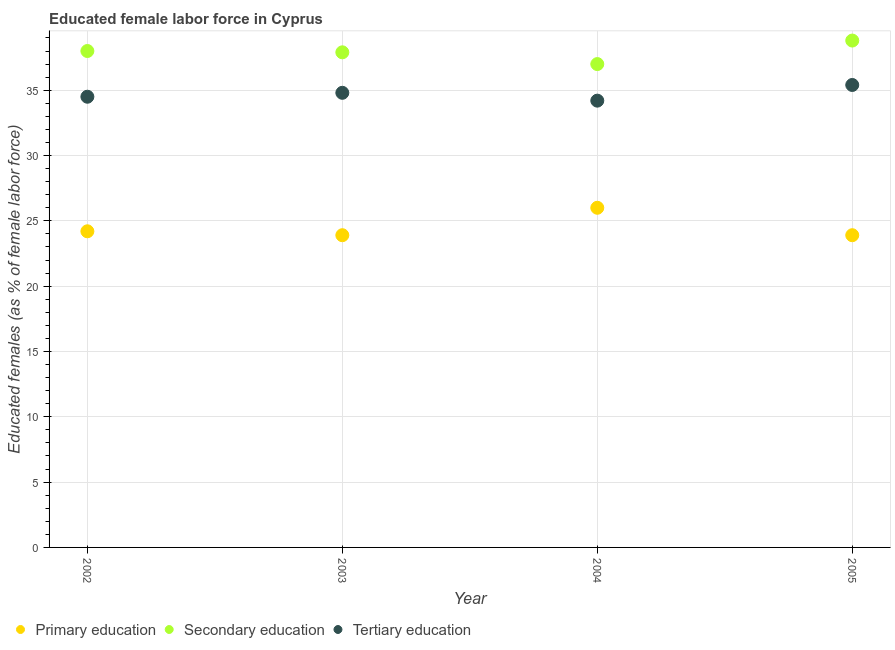Is the number of dotlines equal to the number of legend labels?
Keep it short and to the point. Yes. What is the percentage of female labor force who received primary education in 2002?
Offer a terse response. 24.2. Across all years, what is the minimum percentage of female labor force who received secondary education?
Your response must be concise. 37. In which year was the percentage of female labor force who received tertiary education minimum?
Offer a terse response. 2004. What is the total percentage of female labor force who received primary education in the graph?
Offer a very short reply. 98. What is the difference between the percentage of female labor force who received secondary education in 2002 and that in 2005?
Offer a very short reply. -0.8. What is the difference between the percentage of female labor force who received primary education in 2005 and the percentage of female labor force who received tertiary education in 2004?
Make the answer very short. -10.3. What is the average percentage of female labor force who received tertiary education per year?
Offer a very short reply. 34.73. In the year 2005, what is the difference between the percentage of female labor force who received primary education and percentage of female labor force who received tertiary education?
Keep it short and to the point. -11.5. What is the ratio of the percentage of female labor force who received secondary education in 2002 to that in 2005?
Keep it short and to the point. 0.98. Is the percentage of female labor force who received primary education in 2002 less than that in 2003?
Keep it short and to the point. No. Is the difference between the percentage of female labor force who received secondary education in 2002 and 2004 greater than the difference between the percentage of female labor force who received primary education in 2002 and 2004?
Provide a succinct answer. Yes. What is the difference between the highest and the second highest percentage of female labor force who received primary education?
Offer a terse response. 1.8. What is the difference between the highest and the lowest percentage of female labor force who received secondary education?
Make the answer very short. 1.8. Does the percentage of female labor force who received tertiary education monotonically increase over the years?
Give a very brief answer. No. Is the percentage of female labor force who received tertiary education strictly greater than the percentage of female labor force who received secondary education over the years?
Provide a short and direct response. No. Is the percentage of female labor force who received primary education strictly less than the percentage of female labor force who received tertiary education over the years?
Keep it short and to the point. Yes. How many dotlines are there?
Offer a very short reply. 3. How many years are there in the graph?
Ensure brevity in your answer.  4. Are the values on the major ticks of Y-axis written in scientific E-notation?
Your response must be concise. No. Does the graph contain any zero values?
Give a very brief answer. No. What is the title of the graph?
Your answer should be compact. Educated female labor force in Cyprus. Does "Taxes" appear as one of the legend labels in the graph?
Give a very brief answer. No. What is the label or title of the Y-axis?
Give a very brief answer. Educated females (as % of female labor force). What is the Educated females (as % of female labor force) of Primary education in 2002?
Make the answer very short. 24.2. What is the Educated females (as % of female labor force) of Tertiary education in 2002?
Offer a very short reply. 34.5. What is the Educated females (as % of female labor force) in Primary education in 2003?
Your answer should be very brief. 23.9. What is the Educated females (as % of female labor force) in Secondary education in 2003?
Provide a short and direct response. 37.9. What is the Educated females (as % of female labor force) in Tertiary education in 2003?
Make the answer very short. 34.8. What is the Educated females (as % of female labor force) of Primary education in 2004?
Your answer should be very brief. 26. What is the Educated females (as % of female labor force) in Tertiary education in 2004?
Provide a short and direct response. 34.2. What is the Educated females (as % of female labor force) in Primary education in 2005?
Your answer should be compact. 23.9. What is the Educated females (as % of female labor force) of Secondary education in 2005?
Provide a succinct answer. 38.8. What is the Educated females (as % of female labor force) in Tertiary education in 2005?
Keep it short and to the point. 35.4. Across all years, what is the maximum Educated females (as % of female labor force) in Primary education?
Your answer should be compact. 26. Across all years, what is the maximum Educated females (as % of female labor force) of Secondary education?
Offer a very short reply. 38.8. Across all years, what is the maximum Educated females (as % of female labor force) of Tertiary education?
Give a very brief answer. 35.4. Across all years, what is the minimum Educated females (as % of female labor force) in Primary education?
Your answer should be compact. 23.9. Across all years, what is the minimum Educated females (as % of female labor force) in Secondary education?
Make the answer very short. 37. Across all years, what is the minimum Educated females (as % of female labor force) in Tertiary education?
Give a very brief answer. 34.2. What is the total Educated females (as % of female labor force) of Primary education in the graph?
Offer a terse response. 98. What is the total Educated females (as % of female labor force) in Secondary education in the graph?
Ensure brevity in your answer.  151.7. What is the total Educated females (as % of female labor force) in Tertiary education in the graph?
Your response must be concise. 138.9. What is the difference between the Educated females (as % of female labor force) of Primary education in 2002 and that in 2003?
Give a very brief answer. 0.3. What is the difference between the Educated females (as % of female labor force) of Tertiary education in 2002 and that in 2004?
Provide a short and direct response. 0.3. What is the difference between the Educated females (as % of female labor force) of Primary education in 2002 and that in 2005?
Provide a succinct answer. 0.3. What is the difference between the Educated females (as % of female labor force) in Secondary education in 2002 and that in 2005?
Offer a very short reply. -0.8. What is the difference between the Educated females (as % of female labor force) of Tertiary education in 2002 and that in 2005?
Your answer should be very brief. -0.9. What is the difference between the Educated females (as % of female labor force) of Primary education in 2003 and that in 2004?
Your answer should be compact. -2.1. What is the difference between the Educated females (as % of female labor force) in Primary education in 2003 and that in 2005?
Offer a terse response. 0. What is the difference between the Educated females (as % of female labor force) of Tertiary education in 2003 and that in 2005?
Offer a very short reply. -0.6. What is the difference between the Educated females (as % of female labor force) in Secondary education in 2004 and that in 2005?
Keep it short and to the point. -1.8. What is the difference between the Educated females (as % of female labor force) of Tertiary education in 2004 and that in 2005?
Provide a short and direct response. -1.2. What is the difference between the Educated females (as % of female labor force) of Primary education in 2002 and the Educated females (as % of female labor force) of Secondary education in 2003?
Provide a short and direct response. -13.7. What is the difference between the Educated females (as % of female labor force) in Primary education in 2002 and the Educated females (as % of female labor force) in Tertiary education in 2003?
Make the answer very short. -10.6. What is the difference between the Educated females (as % of female labor force) of Primary education in 2002 and the Educated females (as % of female labor force) of Secondary education in 2004?
Offer a terse response. -12.8. What is the difference between the Educated females (as % of female labor force) in Primary education in 2002 and the Educated females (as % of female labor force) in Tertiary education in 2004?
Provide a short and direct response. -10. What is the difference between the Educated females (as % of female labor force) in Secondary education in 2002 and the Educated females (as % of female labor force) in Tertiary education in 2004?
Ensure brevity in your answer.  3.8. What is the difference between the Educated females (as % of female labor force) of Primary education in 2002 and the Educated females (as % of female labor force) of Secondary education in 2005?
Your response must be concise. -14.6. What is the difference between the Educated females (as % of female labor force) of Secondary education in 2002 and the Educated females (as % of female labor force) of Tertiary education in 2005?
Offer a terse response. 2.6. What is the difference between the Educated females (as % of female labor force) of Primary education in 2003 and the Educated females (as % of female labor force) of Secondary education in 2004?
Ensure brevity in your answer.  -13.1. What is the difference between the Educated females (as % of female labor force) in Secondary education in 2003 and the Educated females (as % of female labor force) in Tertiary education in 2004?
Ensure brevity in your answer.  3.7. What is the difference between the Educated females (as % of female labor force) of Primary education in 2003 and the Educated females (as % of female labor force) of Secondary education in 2005?
Your answer should be very brief. -14.9. What is the difference between the Educated females (as % of female labor force) in Primary education in 2003 and the Educated females (as % of female labor force) in Tertiary education in 2005?
Offer a terse response. -11.5. What is the difference between the Educated females (as % of female labor force) of Secondary education in 2003 and the Educated females (as % of female labor force) of Tertiary education in 2005?
Your answer should be very brief. 2.5. What is the difference between the Educated females (as % of female labor force) in Primary education in 2004 and the Educated females (as % of female labor force) in Secondary education in 2005?
Your response must be concise. -12.8. What is the difference between the Educated females (as % of female labor force) in Primary education in 2004 and the Educated females (as % of female labor force) in Tertiary education in 2005?
Provide a short and direct response. -9.4. What is the difference between the Educated females (as % of female labor force) of Secondary education in 2004 and the Educated females (as % of female labor force) of Tertiary education in 2005?
Provide a succinct answer. 1.6. What is the average Educated females (as % of female labor force) of Primary education per year?
Your answer should be very brief. 24.5. What is the average Educated females (as % of female labor force) of Secondary education per year?
Ensure brevity in your answer.  37.92. What is the average Educated females (as % of female labor force) of Tertiary education per year?
Make the answer very short. 34.73. In the year 2002, what is the difference between the Educated females (as % of female labor force) in Primary education and Educated females (as % of female labor force) in Secondary education?
Keep it short and to the point. -13.8. In the year 2002, what is the difference between the Educated females (as % of female labor force) in Secondary education and Educated females (as % of female labor force) in Tertiary education?
Give a very brief answer. 3.5. In the year 2003, what is the difference between the Educated females (as % of female labor force) of Primary education and Educated females (as % of female labor force) of Secondary education?
Offer a very short reply. -14. In the year 2003, what is the difference between the Educated females (as % of female labor force) of Secondary education and Educated females (as % of female labor force) of Tertiary education?
Give a very brief answer. 3.1. In the year 2004, what is the difference between the Educated females (as % of female labor force) in Secondary education and Educated females (as % of female labor force) in Tertiary education?
Offer a terse response. 2.8. In the year 2005, what is the difference between the Educated females (as % of female labor force) of Primary education and Educated females (as % of female labor force) of Secondary education?
Ensure brevity in your answer.  -14.9. In the year 2005, what is the difference between the Educated females (as % of female labor force) in Secondary education and Educated females (as % of female labor force) in Tertiary education?
Your answer should be very brief. 3.4. What is the ratio of the Educated females (as % of female labor force) in Primary education in 2002 to that in 2003?
Offer a very short reply. 1.01. What is the ratio of the Educated females (as % of female labor force) in Secondary education in 2002 to that in 2003?
Provide a short and direct response. 1. What is the ratio of the Educated females (as % of female labor force) of Primary education in 2002 to that in 2004?
Offer a very short reply. 0.93. What is the ratio of the Educated females (as % of female labor force) of Tertiary education in 2002 to that in 2004?
Provide a succinct answer. 1.01. What is the ratio of the Educated females (as % of female labor force) in Primary education in 2002 to that in 2005?
Your answer should be compact. 1.01. What is the ratio of the Educated females (as % of female labor force) of Secondary education in 2002 to that in 2005?
Your answer should be compact. 0.98. What is the ratio of the Educated females (as % of female labor force) of Tertiary education in 2002 to that in 2005?
Your response must be concise. 0.97. What is the ratio of the Educated females (as % of female labor force) of Primary education in 2003 to that in 2004?
Provide a succinct answer. 0.92. What is the ratio of the Educated females (as % of female labor force) of Secondary education in 2003 to that in 2004?
Make the answer very short. 1.02. What is the ratio of the Educated females (as % of female labor force) in Tertiary education in 2003 to that in 2004?
Give a very brief answer. 1.02. What is the ratio of the Educated females (as % of female labor force) in Primary education in 2003 to that in 2005?
Give a very brief answer. 1. What is the ratio of the Educated females (as % of female labor force) of Secondary education in 2003 to that in 2005?
Your answer should be compact. 0.98. What is the ratio of the Educated females (as % of female labor force) in Tertiary education in 2003 to that in 2005?
Provide a short and direct response. 0.98. What is the ratio of the Educated females (as % of female labor force) in Primary education in 2004 to that in 2005?
Offer a terse response. 1.09. What is the ratio of the Educated females (as % of female labor force) in Secondary education in 2004 to that in 2005?
Offer a very short reply. 0.95. What is the ratio of the Educated females (as % of female labor force) in Tertiary education in 2004 to that in 2005?
Provide a short and direct response. 0.97. What is the difference between the highest and the second highest Educated females (as % of female labor force) in Secondary education?
Give a very brief answer. 0.8. What is the difference between the highest and the second highest Educated females (as % of female labor force) in Tertiary education?
Provide a succinct answer. 0.6. What is the difference between the highest and the lowest Educated females (as % of female labor force) in Primary education?
Provide a short and direct response. 2.1. What is the difference between the highest and the lowest Educated females (as % of female labor force) in Tertiary education?
Give a very brief answer. 1.2. 